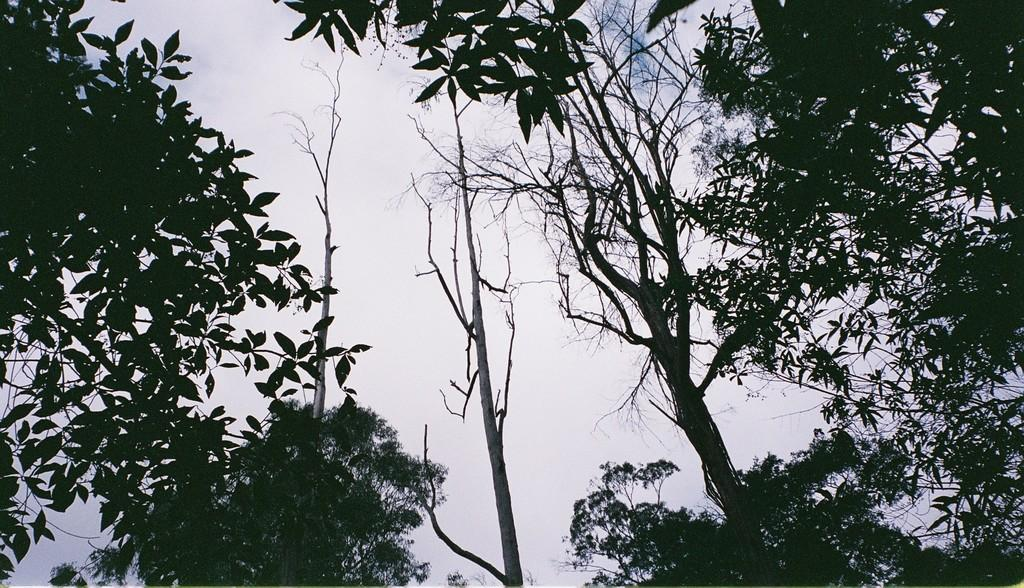What type of vegetation can be seen in the image? There are trees in the image. What can be seen in the sky in the background of the image? There are clouds in the sky in the background of the image. What is the opinion of the lamp in the image? There is no lamp present in the image, so it is not possible to determine its opinion. 